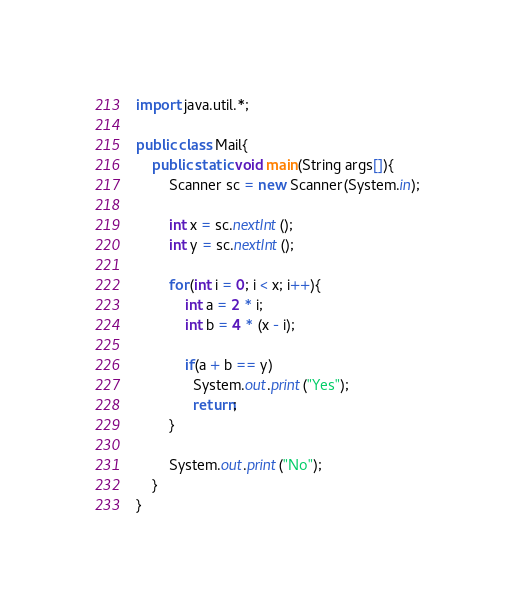Convert code to text. <code><loc_0><loc_0><loc_500><loc_500><_Java_>import java.util.*;

public class Mail{
	public static void main(String args[]){
    	Scanner sc = new Scanner(System.in);
      
      	int x = sc.nextInt();
      	int y = sc.nextInt();
      
        for(int i = 0; i < x; i++){
        	int a = 2 * i;
          	int b = 4 * (x - i);
          	
          	if(a + b == y)
              System.out.print("Yes");
          	  return;
        }
      	
        System.out.print("No");
    }
}
</code> 